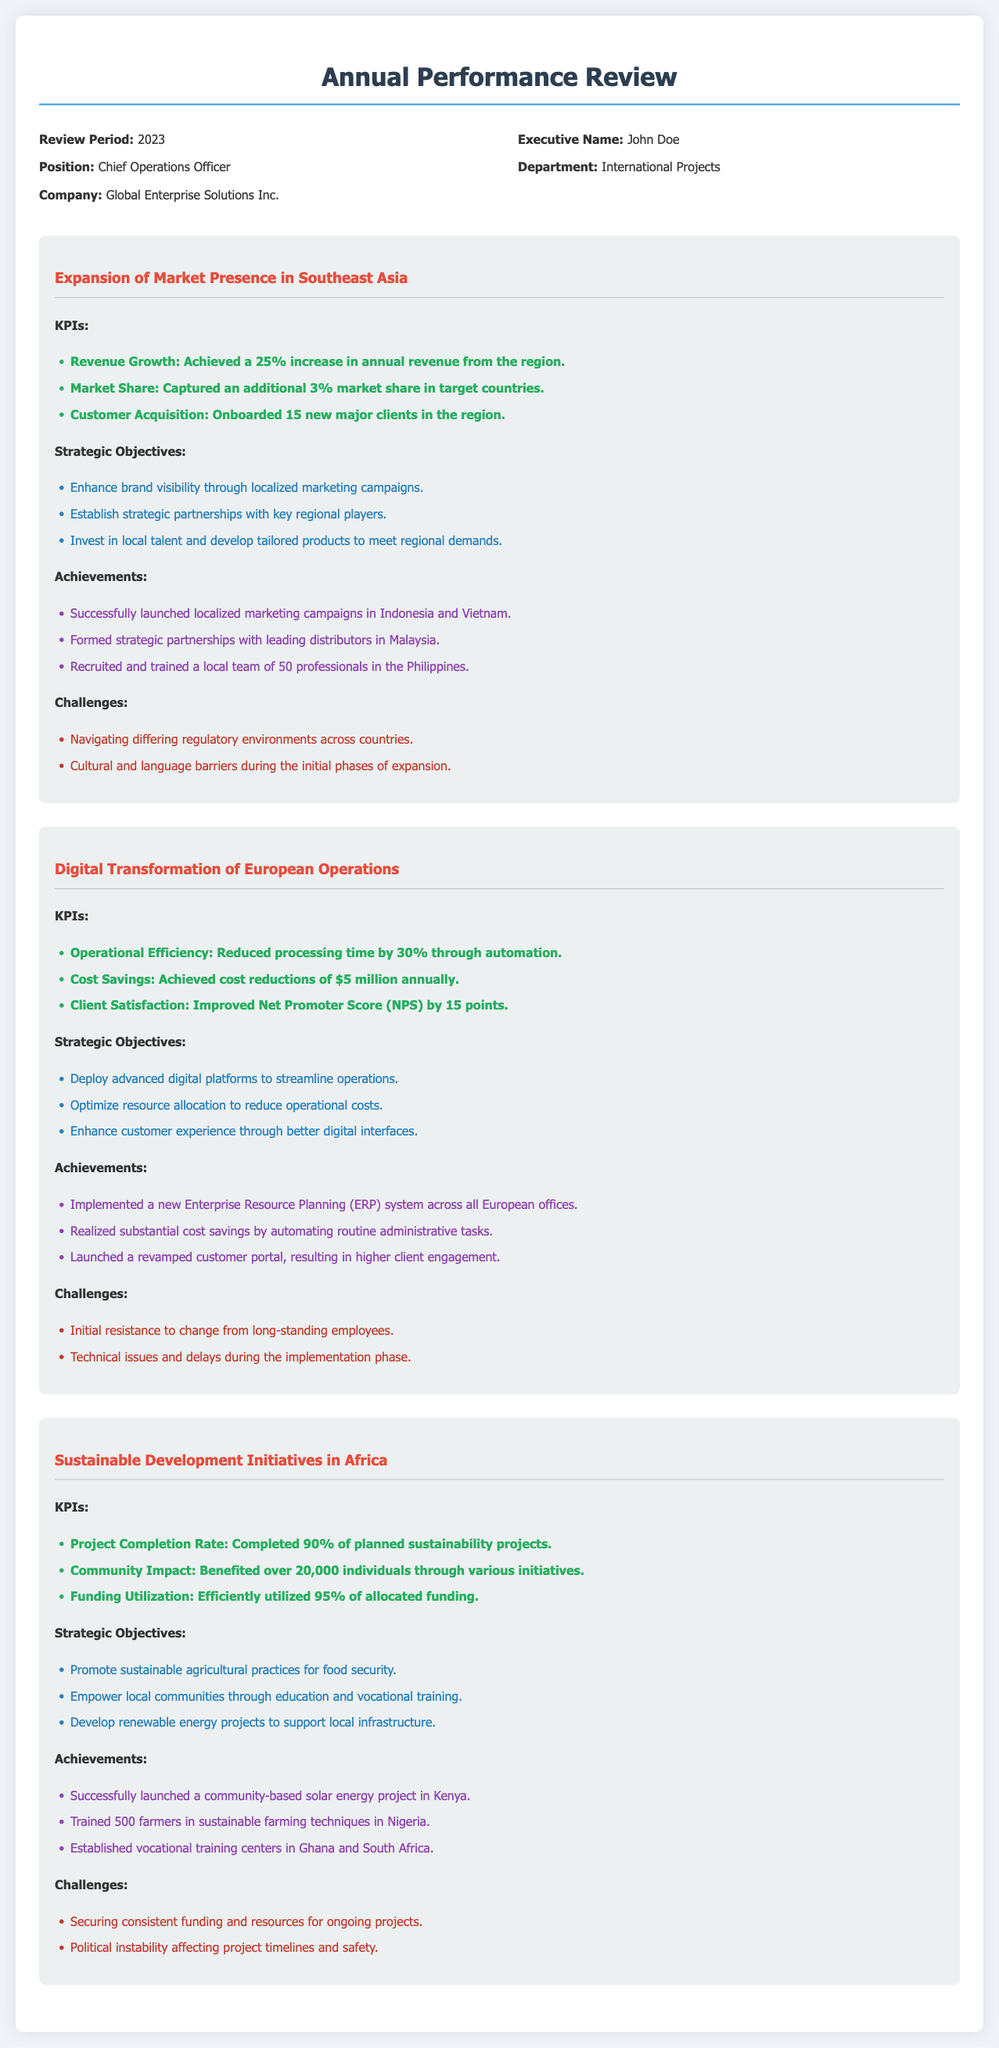what is the review period? The review period is specified in the header information of the document.
Answer: 2023 who is the Executive Name? The executive name is mentioned in the header information section.
Answer: John Doe how many new major clients were onboarded in Southeast Asia? The number of new major clients is provided under the KPIs for the Southeast Asia expansion project.
Answer: 15 what was the percentage increase in annual revenue from Southeast Asia? The percentage increase in annual revenue is listed in the KPIs for the Southeast Asia expansion project.
Answer: 25% what was the annual cost savings achieved in the Digital Transformation project? The annual cost savings are stated under the KPIs for the Digital Transformation of European Operations project.
Answer: $5 million how many projects were completed in the Sustainable Development Initiatives? The project completion rate is included among the KPIs for the Sustainable Development Initiatives in Africa.
Answer: 90% what is one of the strategic objectives for the Sustainable Development Initiatives? One of the strategic objectives is found under the objectives section for the Sustainable Development Initiatives in Africa.
Answer: Promote sustainable agricultural practices for food security what challenge did the Digital Transformation project face? A challenge faced during the Digital Transformation of European Operations is mentioned in the challenges section.
Answer: Initial resistance to change from long-standing employees how many individuals were benefited through the Sustainable Development Initiatives? The number of individuals benefited is indicated in the KPIs for the Sustainable Development Initiatives in Africa.
Answer: 20,000 